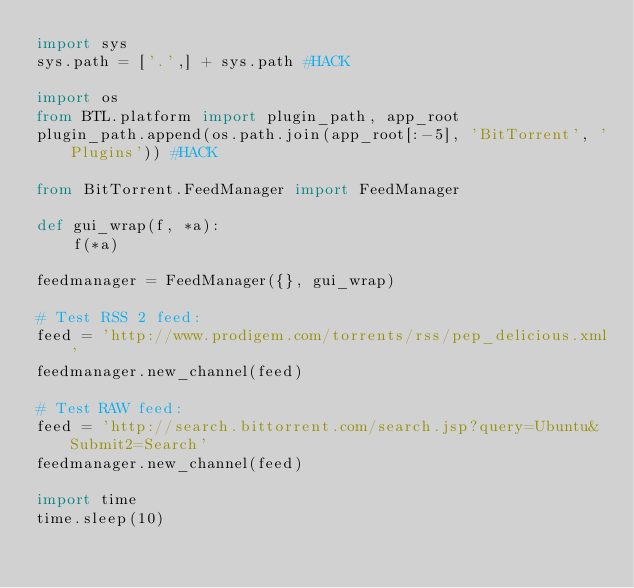<code> <loc_0><loc_0><loc_500><loc_500><_Python_>import sys
sys.path = ['.',] + sys.path #HACK

import os
from BTL.platform import plugin_path, app_root
plugin_path.append(os.path.join(app_root[:-5], 'BitTorrent', 'Plugins')) #HACK

from BitTorrent.FeedManager import FeedManager

def gui_wrap(f, *a):
    f(*a)

feedmanager = FeedManager({}, gui_wrap)

# Test RSS 2 feed:
feed = 'http://www.prodigem.com/torrents/rss/pep_delicious.xml'
feedmanager.new_channel(feed)

# Test RAW feed:
feed = 'http://search.bittorrent.com/search.jsp?query=Ubuntu&Submit2=Search'
feedmanager.new_channel(feed)

import time
time.sleep(10)
</code> 